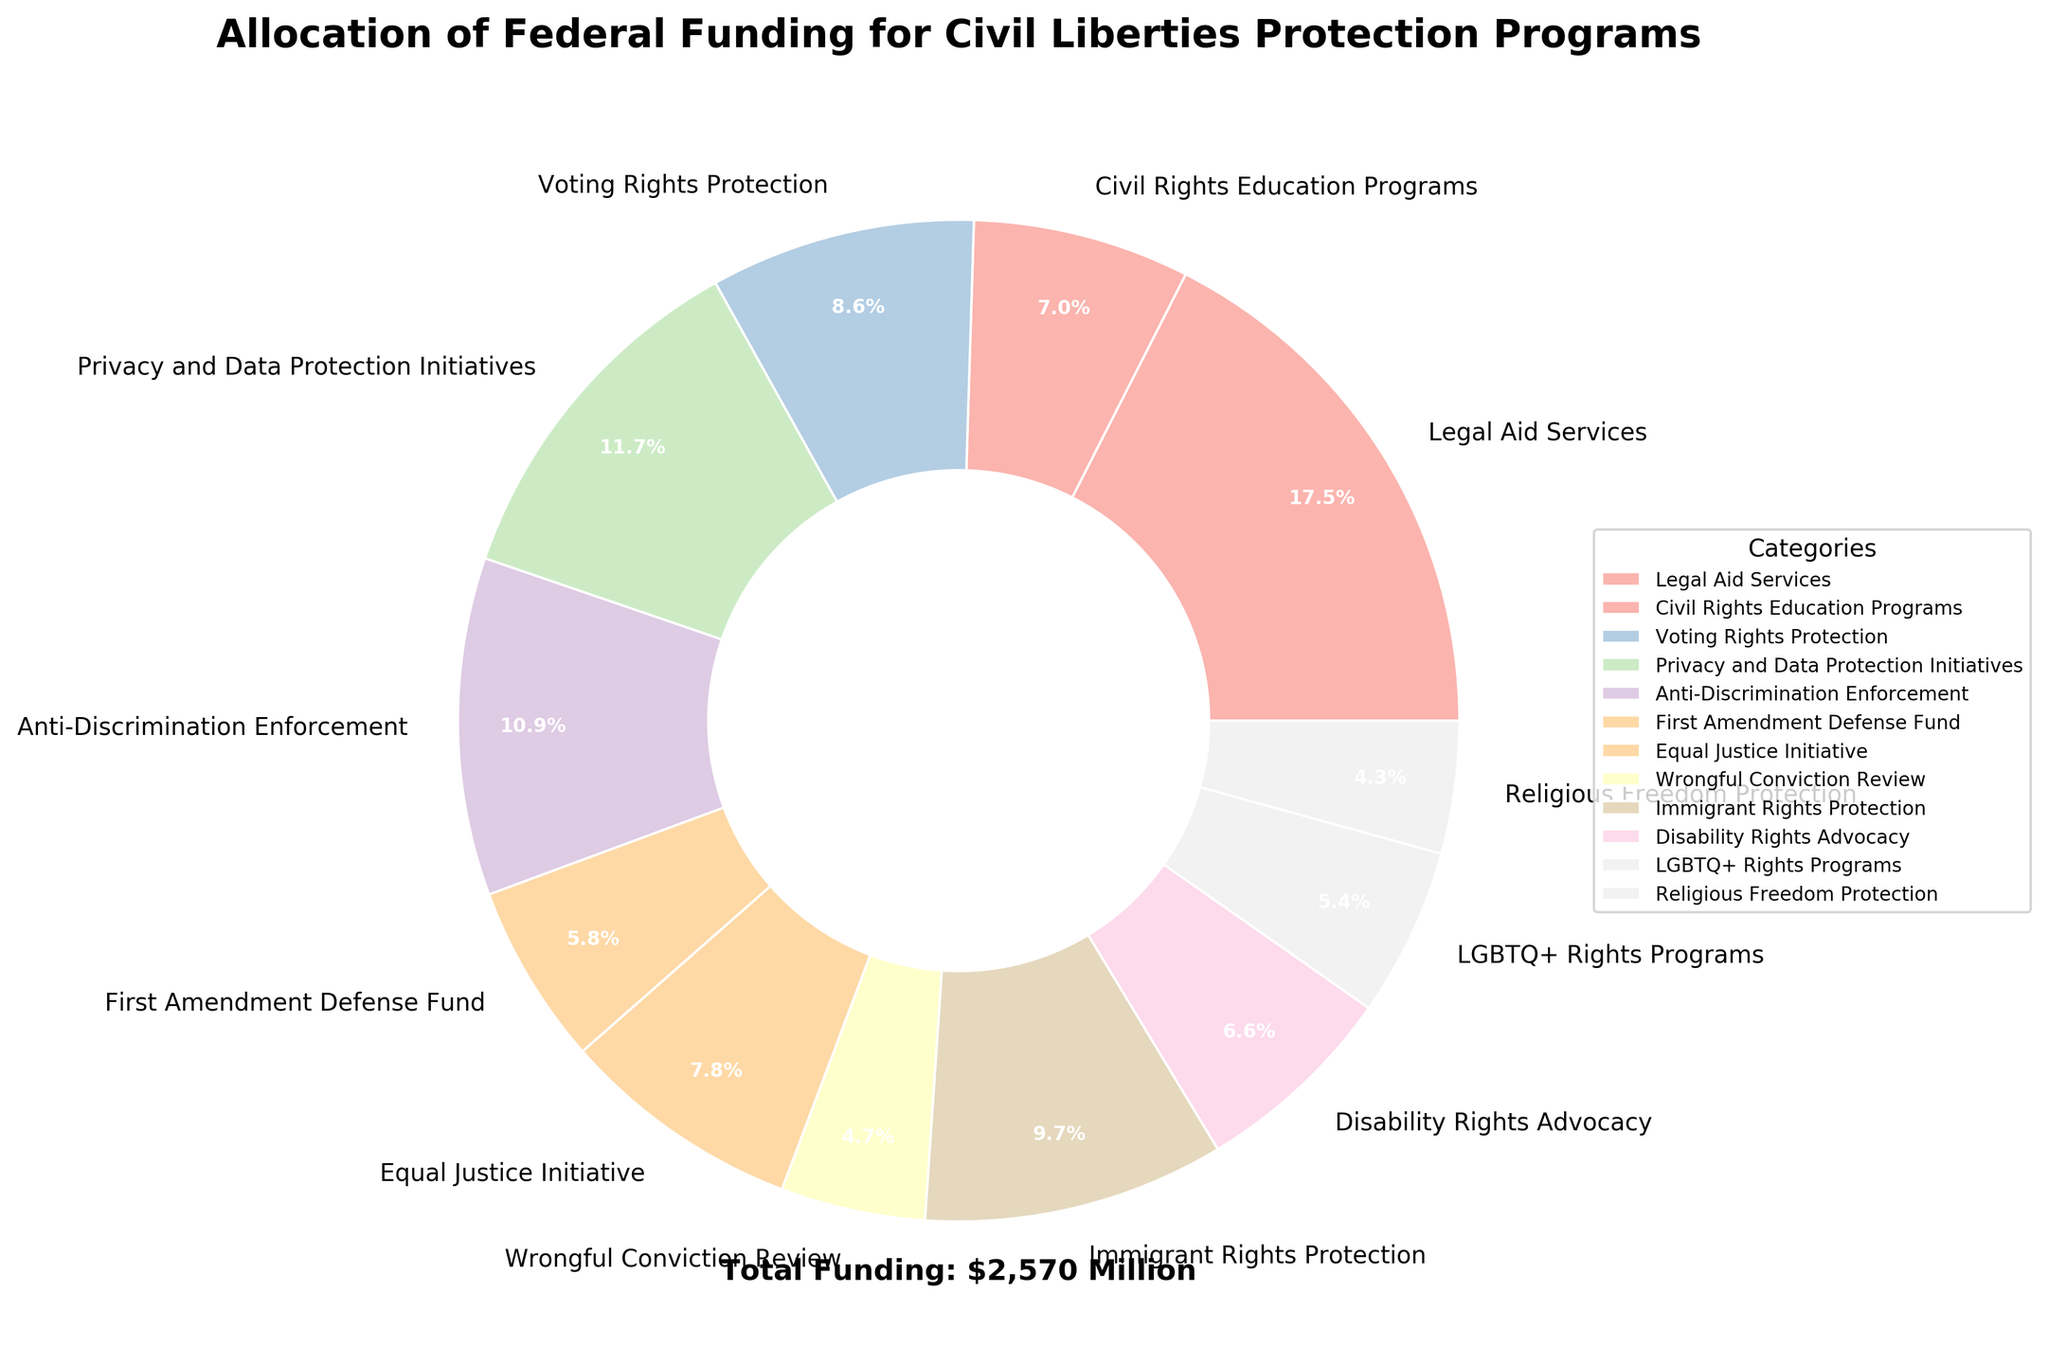What category receives the highest federal funding? By looking at the figure, it's evident that the segment representing "Legal Aid Services" is the largest. This indicates that it receives the highest amount of funding.
Answer: Legal Aid Services What is the total funding for the smallest three categories? The smallest segments are for "Religious Freedom Protection", "Wrongful Conviction Review", and "LGBTQ+ Rights Programs". Summing their funding amounts: $110M + $120M + $140M = $370M.
Answer: $370M How much more funding does Privacy and Data Protection Initiatives receive compared to Voting Rights Protection? The Privacy and Data Protection Initiatives receive $300M, while Voting Rights Protection receives $220M. The difference is $300M - $220M = $80M.
Answer: $80M Which category has a funding amount closest to the median funding amount of all the categories? First, list all funding amounts in order: 110, 120, 140, 150, 170, 180, 200, 220, 250, 280, 300, 450. The median for 12 numbers is the average of the 6th and 7th values: (180 + 200) / 2 = 190. "Disability Rights Advocacy" at $170M, and "Equal Justice Initiative" at $200M are closest; "Equal Justice Initiative" being slightly closer.
Answer: Equal Justice Initiative Which categories combined account for more than half of the total funding? The combined total funding is $2,570M. Half of this is $1,285M. By adding the categories starting from the largest: Legal Aid Services ($450M) + Privacy and Data Protection Initiatives ($300M) + Anti-Discrimination Enforcement ($280M) + Immigrant Rights Protection ($250M) + Voting Rights Protection ($220M), the cumulative total is $1,500M which is more than half. Therefore, these five categories account for more than half the funding.
Answer: Legal Aid Services, Privacy and Data Protection Initiatives, Anti-Discrimination Enforcement, Immigrant Rights Protection, Voting Rights Protection What percentage of the total funding does the Anti-Discrimination Enforcement receive? Anti-Discrimination Enforcement receives $280M. The total funding is $2,570M. The percentage is calculated as ($280M / $2,570M) * 100 ≈ 10.89%.
Answer: 10.89% Are there more programs receiving less than $200M than those receiving more? There are 7 categories receiving less than $200M: Civil Rights Education Programs, Wrongful Conviction Review, Disability Rights Advocacy, LGBTQ+ Rights Programs, Religious Freedom Protection, First Amendment Defense Fund, and Equal Justice Initiative. The remaining 5 receive more than $200M.
Answer: Yes Which color is used to represent the category with the most funding? The largest segment in the pie chart, representing "Legal Aid Services", is typically colored using a pastel color from the palette. This can be visually identified without exact color names.
Answer: The largest pastel color How many categories receive funding between $100M and $300M? The categories falling within $100M and $300M are: Civil Rights Education Programs ($180M), Voting Rights Protection ($220M), Anti-Discrimination Enforcement ($280M), First Amendment Defense Fund ($150M), Equal Justice Initiative ($200M), Wrongful Conviction Review ($120M), Immigrant Rights Protection ($250M), and Disability Rights Advocacy ($170M). Counts to 8 categories.
Answer: 8 